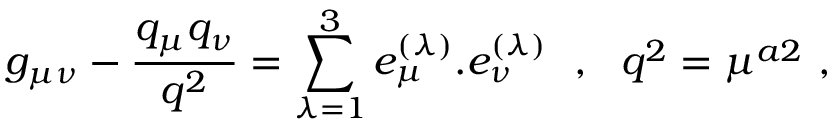Convert formula to latex. <formula><loc_0><loc_0><loc_500><loc_500>g _ { \mu \nu } - { \frac { q _ { \mu } q _ { \nu } } { q ^ { 2 } } } = \sum _ { \lambda = 1 } ^ { 3 } e _ { \mu } ^ { ( \lambda ) } . e _ { \nu } ^ { ( \lambda ) } , q ^ { 2 } = \mu ^ { a 2 } \ ,</formula> 